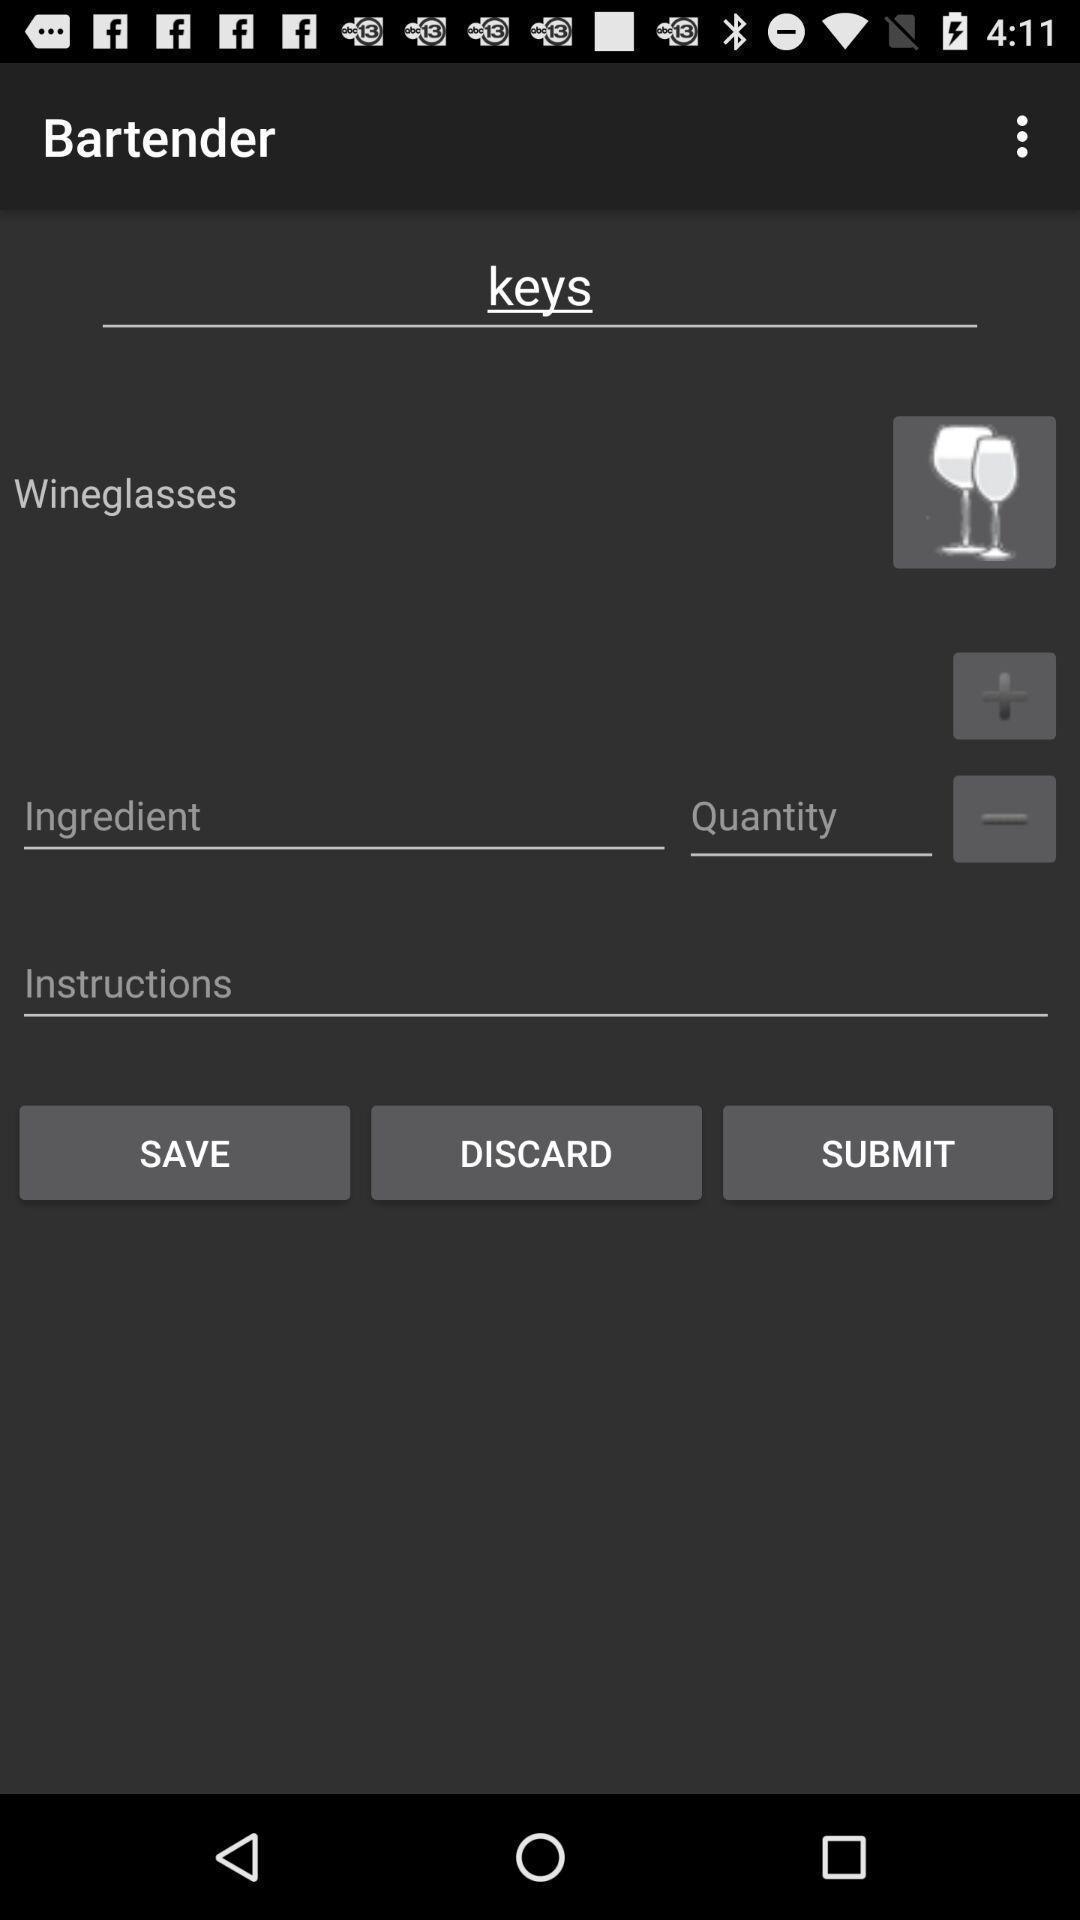Describe the visual elements of this screenshot. Page showing various options related to a bar-tending app. 